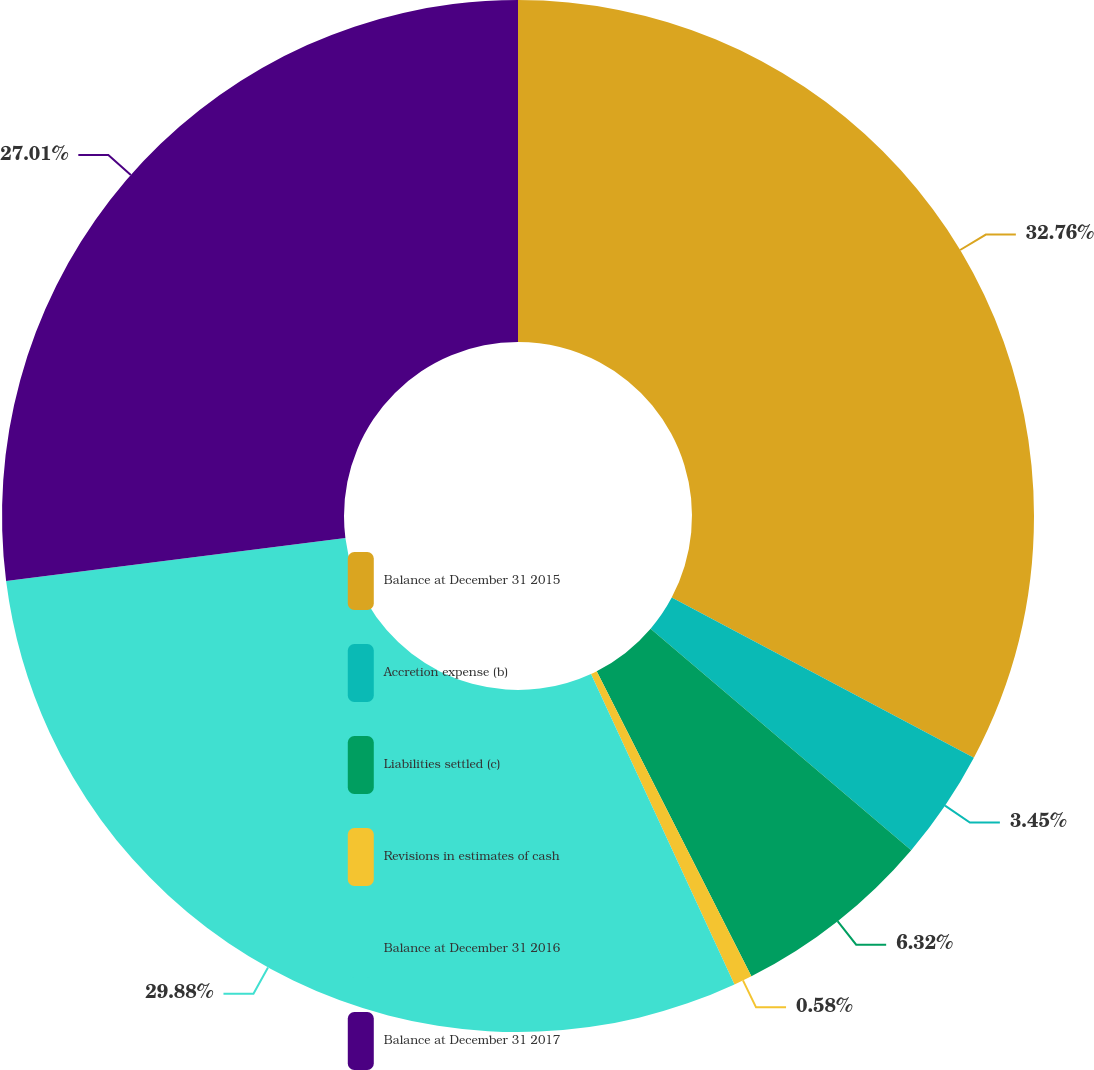Convert chart to OTSL. <chart><loc_0><loc_0><loc_500><loc_500><pie_chart><fcel>Balance at December 31 2015<fcel>Accretion expense (b)<fcel>Liabilities settled (c)<fcel>Revisions in estimates of cash<fcel>Balance at December 31 2016<fcel>Balance at December 31 2017<nl><fcel>32.76%<fcel>3.45%<fcel>6.32%<fcel>0.58%<fcel>29.88%<fcel>27.01%<nl></chart> 